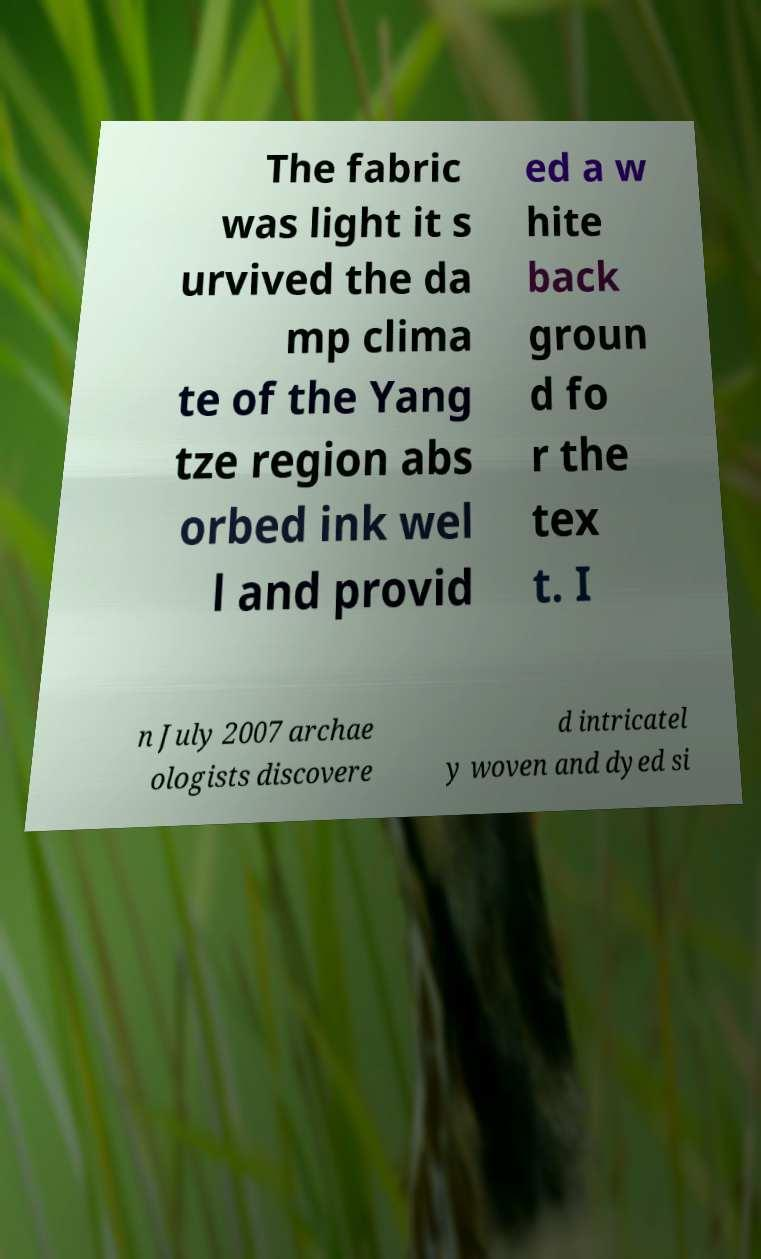What messages or text are displayed in this image? I need them in a readable, typed format. The fabric was light it s urvived the da mp clima te of the Yang tze region abs orbed ink wel l and provid ed a w hite back groun d fo r the tex t. I n July 2007 archae ologists discovere d intricatel y woven and dyed si 